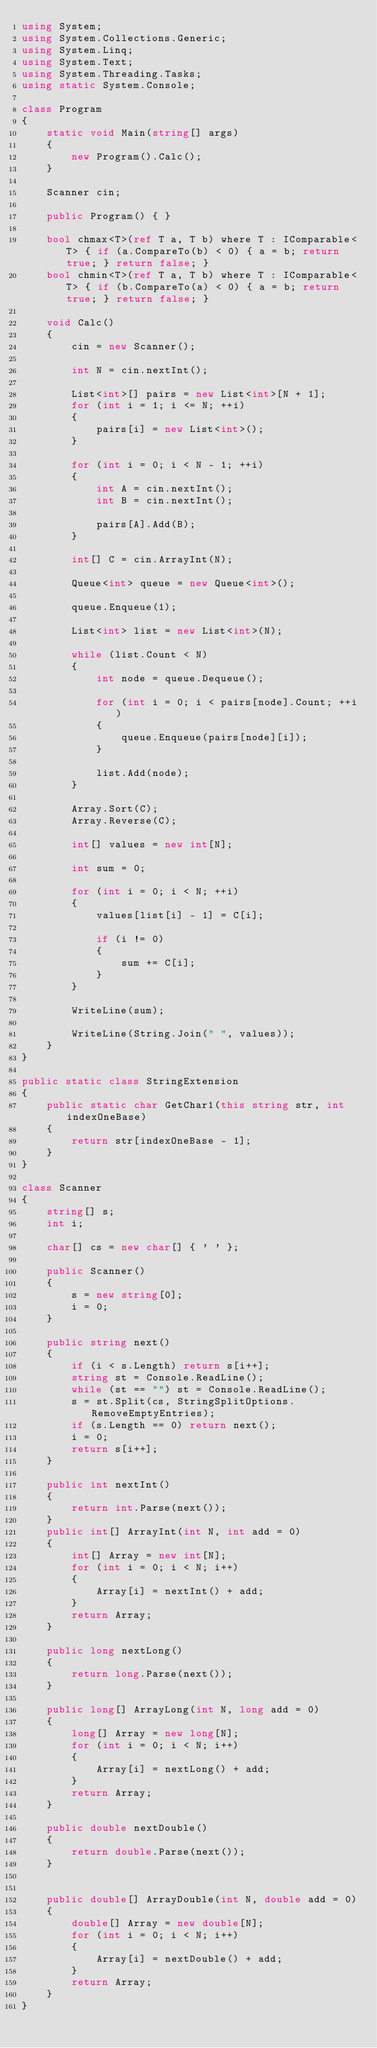Convert code to text. <code><loc_0><loc_0><loc_500><loc_500><_C#_>using System;
using System.Collections.Generic;
using System.Linq;
using System.Text;
using System.Threading.Tasks;
using static System.Console;

class Program
{
    static void Main(string[] args)
    {
        new Program().Calc();
    }

    Scanner cin;

    public Program() { }

    bool chmax<T>(ref T a, T b) where T : IComparable<T> { if (a.CompareTo(b) < 0) { a = b; return true; } return false; }
    bool chmin<T>(ref T a, T b) where T : IComparable<T> { if (b.CompareTo(a) < 0) { a = b; return true; } return false; }

    void Calc()
    {
        cin = new Scanner();

        int N = cin.nextInt();

        List<int>[] pairs = new List<int>[N + 1];
        for (int i = 1; i <= N; ++i)
        {
            pairs[i] = new List<int>();
        }

        for (int i = 0; i < N - 1; ++i)
        {
            int A = cin.nextInt();
            int B = cin.nextInt();

            pairs[A].Add(B);
        }

        int[] C = cin.ArrayInt(N);

        Queue<int> queue = new Queue<int>();

        queue.Enqueue(1);

        List<int> list = new List<int>(N);

        while (list.Count < N)
        {
            int node = queue.Dequeue();

            for (int i = 0; i < pairs[node].Count; ++i)
            {
                queue.Enqueue(pairs[node][i]);
            }

            list.Add(node);
        }

        Array.Sort(C);
        Array.Reverse(C);

        int[] values = new int[N];

        int sum = 0;

        for (int i = 0; i < N; ++i)
        {
            values[list[i] - 1] = C[i];

            if (i != 0)
            {
                sum += C[i];
            }
        }

        WriteLine(sum);

        WriteLine(String.Join(" ", values));
    }
}

public static class StringExtension
{
    public static char GetChar1(this string str, int indexOneBase)
    {
        return str[indexOneBase - 1];
    }
}

class Scanner
{
    string[] s;
    int i;

    char[] cs = new char[] { ' ' };

    public Scanner()
    {
        s = new string[0];
        i = 0;
    }

    public string next()
    {
        if (i < s.Length) return s[i++];
        string st = Console.ReadLine();
        while (st == "") st = Console.ReadLine();
        s = st.Split(cs, StringSplitOptions.RemoveEmptyEntries);
        if (s.Length == 0) return next();
        i = 0;
        return s[i++];
    }

    public int nextInt()
    {
        return int.Parse(next());
    }
    public int[] ArrayInt(int N, int add = 0)
    {
        int[] Array = new int[N];
        for (int i = 0; i < N; i++)
        {
            Array[i] = nextInt() + add;
        }
        return Array;
    }

    public long nextLong()
    {
        return long.Parse(next());
    }

    public long[] ArrayLong(int N, long add = 0)
    {
        long[] Array = new long[N];
        for (int i = 0; i < N; i++)
        {
            Array[i] = nextLong() + add;
        }
        return Array;
    }

    public double nextDouble()
    {
        return double.Parse(next());
    }


    public double[] ArrayDouble(int N, double add = 0)
    {
        double[] Array = new double[N];
        for (int i = 0; i < N; i++)
        {
            Array[i] = nextDouble() + add;
        }
        return Array;
    }
}
</code> 